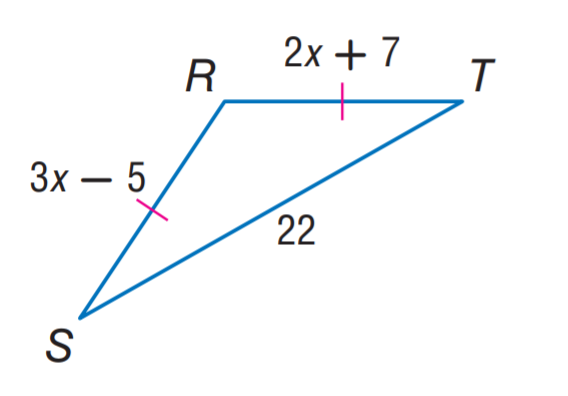Answer the mathemtical geometry problem and directly provide the correct option letter.
Question: Find R S.
Choices: A: 12 B: 22 C: 31 D: 33 C 